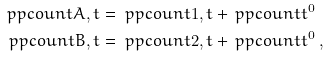Convert formula to latex. <formula><loc_0><loc_0><loc_500><loc_500>\ p p c o u n t { A , t } & = \ p p c o u n t { 1 , t } + \ p p c o u n t { t } ^ { 0 } \\ \ p p c o u n t { B , t } & = \ p p c o u n t { 2 , t } + \ p p c o u n t { t } ^ { 0 } \, ,</formula> 